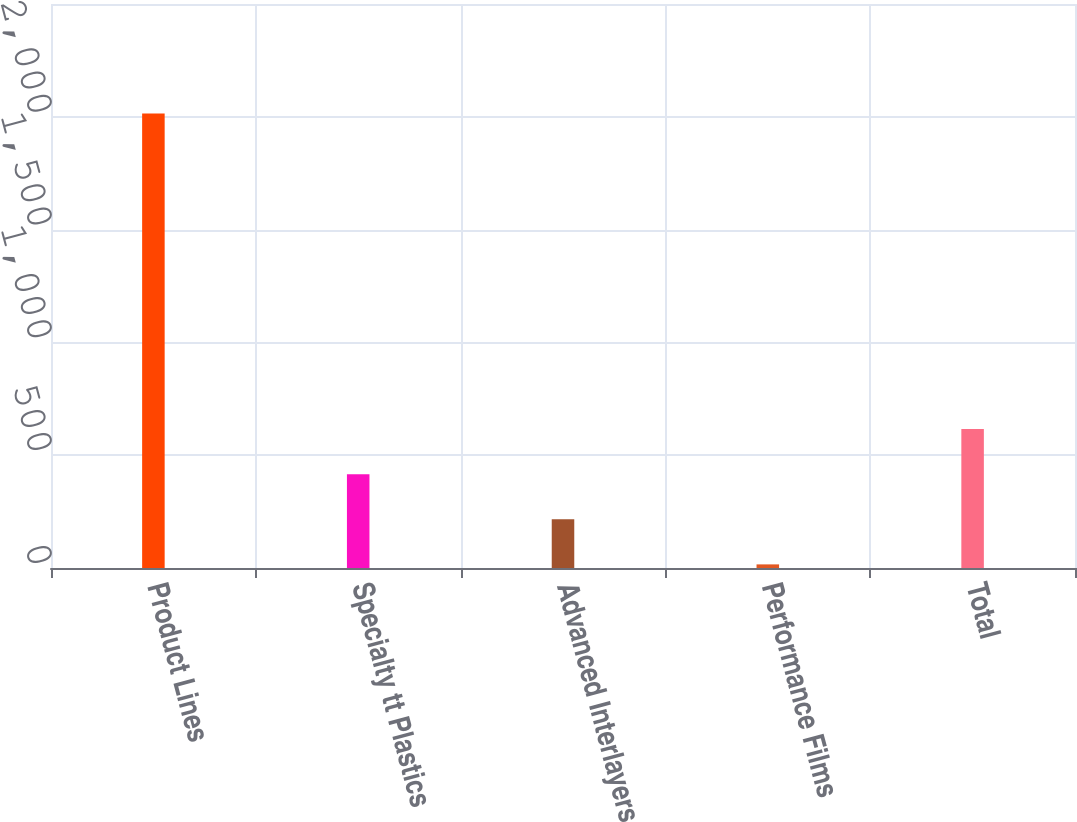<chart> <loc_0><loc_0><loc_500><loc_500><bar_chart><fcel>Product Lines<fcel>Specialty tt Plastics<fcel>Advanced Interlayers<fcel>Performance Films<fcel>Total<nl><fcel>2015<fcel>415.8<fcel>215.9<fcel>16<fcel>615.7<nl></chart> 